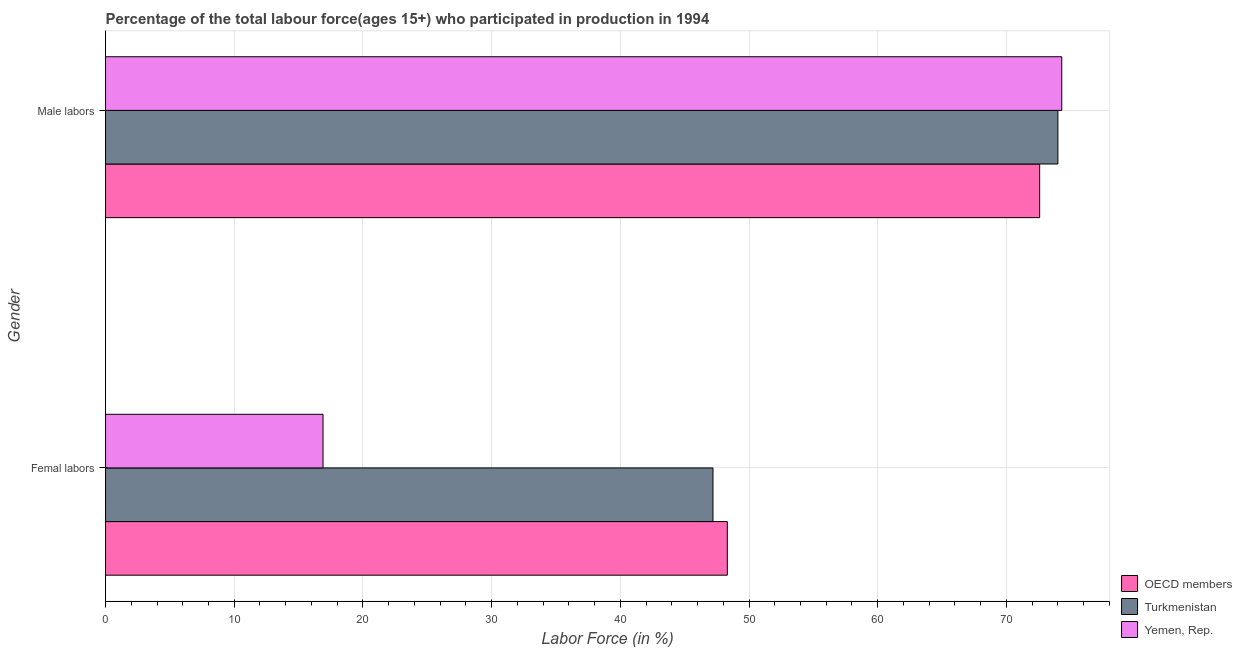What is the label of the 2nd group of bars from the top?
Your response must be concise. Femal labors. What is the percentage of male labour force in Yemen, Rep.?
Make the answer very short. 74.3. Across all countries, what is the maximum percentage of female labor force?
Keep it short and to the point. 48.31. Across all countries, what is the minimum percentage of female labor force?
Your answer should be very brief. 16.9. In which country was the percentage of female labor force maximum?
Provide a succinct answer. OECD members. In which country was the percentage of female labor force minimum?
Offer a very short reply. Yemen, Rep. What is the total percentage of male labour force in the graph?
Ensure brevity in your answer.  220.88. What is the difference between the percentage of male labour force in Turkmenistan and that in Yemen, Rep.?
Ensure brevity in your answer.  -0.3. What is the difference between the percentage of female labor force in OECD members and the percentage of male labour force in Yemen, Rep.?
Your answer should be compact. -25.99. What is the average percentage of male labour force per country?
Provide a short and direct response. 73.63. What is the difference between the percentage of male labour force and percentage of female labor force in Yemen, Rep.?
Your answer should be compact. 57.4. In how many countries, is the percentage of female labor force greater than 8 %?
Provide a short and direct response. 3. What is the ratio of the percentage of male labour force in OECD members to that in Yemen, Rep.?
Offer a very short reply. 0.98. In how many countries, is the percentage of female labor force greater than the average percentage of female labor force taken over all countries?
Your answer should be compact. 2. What does the 1st bar from the top in Male labors represents?
Keep it short and to the point. Yemen, Rep. What does the 2nd bar from the bottom in Femal labors represents?
Make the answer very short. Turkmenistan. What is the difference between two consecutive major ticks on the X-axis?
Ensure brevity in your answer.  10. How are the legend labels stacked?
Give a very brief answer. Vertical. What is the title of the graph?
Your answer should be compact. Percentage of the total labour force(ages 15+) who participated in production in 1994. What is the label or title of the X-axis?
Offer a very short reply. Labor Force (in %). What is the label or title of the Y-axis?
Keep it short and to the point. Gender. What is the Labor Force (in %) in OECD members in Femal labors?
Keep it short and to the point. 48.31. What is the Labor Force (in %) in Turkmenistan in Femal labors?
Make the answer very short. 47.2. What is the Labor Force (in %) in Yemen, Rep. in Femal labors?
Keep it short and to the point. 16.9. What is the Labor Force (in %) of OECD members in Male labors?
Give a very brief answer. 72.58. What is the Labor Force (in %) of Turkmenistan in Male labors?
Make the answer very short. 74. What is the Labor Force (in %) of Yemen, Rep. in Male labors?
Your answer should be compact. 74.3. Across all Gender, what is the maximum Labor Force (in %) of OECD members?
Keep it short and to the point. 72.58. Across all Gender, what is the maximum Labor Force (in %) in Turkmenistan?
Give a very brief answer. 74. Across all Gender, what is the maximum Labor Force (in %) of Yemen, Rep.?
Offer a terse response. 74.3. Across all Gender, what is the minimum Labor Force (in %) in OECD members?
Your response must be concise. 48.31. Across all Gender, what is the minimum Labor Force (in %) in Turkmenistan?
Keep it short and to the point. 47.2. Across all Gender, what is the minimum Labor Force (in %) in Yemen, Rep.?
Keep it short and to the point. 16.9. What is the total Labor Force (in %) in OECD members in the graph?
Provide a succinct answer. 120.9. What is the total Labor Force (in %) of Turkmenistan in the graph?
Provide a succinct answer. 121.2. What is the total Labor Force (in %) of Yemen, Rep. in the graph?
Make the answer very short. 91.2. What is the difference between the Labor Force (in %) in OECD members in Femal labors and that in Male labors?
Provide a short and direct response. -24.27. What is the difference between the Labor Force (in %) of Turkmenistan in Femal labors and that in Male labors?
Make the answer very short. -26.8. What is the difference between the Labor Force (in %) in Yemen, Rep. in Femal labors and that in Male labors?
Make the answer very short. -57.4. What is the difference between the Labor Force (in %) of OECD members in Femal labors and the Labor Force (in %) of Turkmenistan in Male labors?
Your response must be concise. -25.69. What is the difference between the Labor Force (in %) of OECD members in Femal labors and the Labor Force (in %) of Yemen, Rep. in Male labors?
Your answer should be compact. -25.99. What is the difference between the Labor Force (in %) of Turkmenistan in Femal labors and the Labor Force (in %) of Yemen, Rep. in Male labors?
Make the answer very short. -27.1. What is the average Labor Force (in %) of OECD members per Gender?
Your response must be concise. 60.45. What is the average Labor Force (in %) in Turkmenistan per Gender?
Your answer should be compact. 60.6. What is the average Labor Force (in %) of Yemen, Rep. per Gender?
Your answer should be compact. 45.6. What is the difference between the Labor Force (in %) in OECD members and Labor Force (in %) in Turkmenistan in Femal labors?
Make the answer very short. 1.11. What is the difference between the Labor Force (in %) of OECD members and Labor Force (in %) of Yemen, Rep. in Femal labors?
Your answer should be compact. 31.41. What is the difference between the Labor Force (in %) of Turkmenistan and Labor Force (in %) of Yemen, Rep. in Femal labors?
Keep it short and to the point. 30.3. What is the difference between the Labor Force (in %) of OECD members and Labor Force (in %) of Turkmenistan in Male labors?
Offer a very short reply. -1.42. What is the difference between the Labor Force (in %) of OECD members and Labor Force (in %) of Yemen, Rep. in Male labors?
Your response must be concise. -1.72. What is the ratio of the Labor Force (in %) of OECD members in Femal labors to that in Male labors?
Ensure brevity in your answer.  0.67. What is the ratio of the Labor Force (in %) in Turkmenistan in Femal labors to that in Male labors?
Provide a short and direct response. 0.64. What is the ratio of the Labor Force (in %) of Yemen, Rep. in Femal labors to that in Male labors?
Give a very brief answer. 0.23. What is the difference between the highest and the second highest Labor Force (in %) in OECD members?
Give a very brief answer. 24.27. What is the difference between the highest and the second highest Labor Force (in %) in Turkmenistan?
Provide a succinct answer. 26.8. What is the difference between the highest and the second highest Labor Force (in %) in Yemen, Rep.?
Make the answer very short. 57.4. What is the difference between the highest and the lowest Labor Force (in %) of OECD members?
Your response must be concise. 24.27. What is the difference between the highest and the lowest Labor Force (in %) of Turkmenistan?
Offer a very short reply. 26.8. What is the difference between the highest and the lowest Labor Force (in %) of Yemen, Rep.?
Make the answer very short. 57.4. 